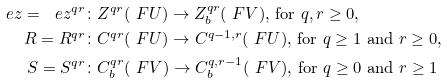Convert formula to latex. <formula><loc_0><loc_0><loc_500><loc_500>\ e z = \ e z ^ { q r } & \colon Z ^ { q r } ( \ F U ) \to Z ^ { q r } _ { b } ( \ F V ) \text {, for } q , r \geq 0 \text {,} \\ R = R ^ { q r } & \colon C ^ { q r } ( \ F U ) \to C ^ { q - 1 , r } ( \ F U ) \text {, for } q \geq 1 \text { and } r \geq 0 \text {,} \\ S = S ^ { q r } & \colon C ^ { q r } _ { b } ( \ F V ) \to C ^ { q , r - 1 } _ { b } ( \ F V ) \text {, for } q \geq 0 \text { and } r \geq 1</formula> 